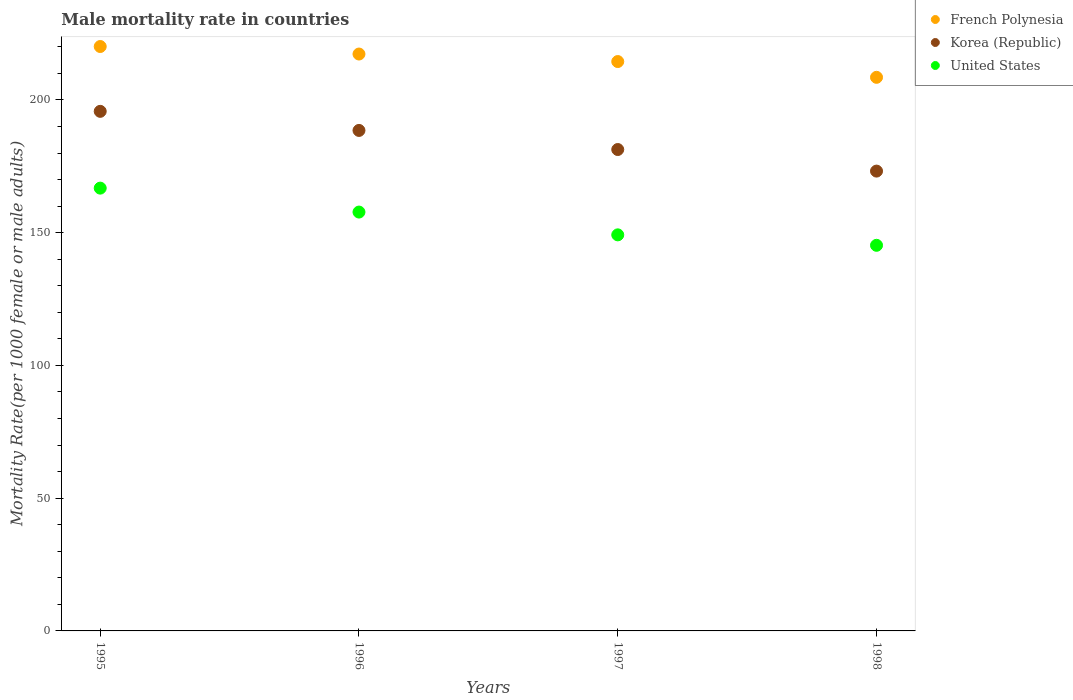Is the number of dotlines equal to the number of legend labels?
Offer a very short reply. Yes. What is the male mortality rate in Korea (Republic) in 1998?
Your response must be concise. 173.2. Across all years, what is the maximum male mortality rate in French Polynesia?
Provide a succinct answer. 220.13. Across all years, what is the minimum male mortality rate in French Polynesia?
Offer a terse response. 208.53. What is the total male mortality rate in French Polynesia in the graph?
Your answer should be very brief. 860.42. What is the difference between the male mortality rate in French Polynesia in 1995 and that in 1998?
Ensure brevity in your answer.  11.6. What is the difference between the male mortality rate in United States in 1995 and the male mortality rate in Korea (Republic) in 1996?
Your answer should be compact. -21.73. What is the average male mortality rate in United States per year?
Provide a succinct answer. 154.75. In the year 1995, what is the difference between the male mortality rate in Korea (Republic) and male mortality rate in French Polynesia?
Your answer should be compact. -24.42. What is the ratio of the male mortality rate in United States in 1996 to that in 1997?
Your answer should be compact. 1.06. Is the male mortality rate in French Polynesia in 1995 less than that in 1998?
Your answer should be compact. No. Is the difference between the male mortality rate in Korea (Republic) in 1995 and 1996 greater than the difference between the male mortality rate in French Polynesia in 1995 and 1996?
Give a very brief answer. Yes. What is the difference between the highest and the second highest male mortality rate in Korea (Republic)?
Keep it short and to the point. 7.19. What is the difference between the highest and the lowest male mortality rate in United States?
Offer a very short reply. 21.54. In how many years, is the male mortality rate in United States greater than the average male mortality rate in United States taken over all years?
Offer a very short reply. 2. Is the sum of the male mortality rate in United States in 1996 and 1998 greater than the maximum male mortality rate in Korea (Republic) across all years?
Offer a terse response. Yes. Is the male mortality rate in United States strictly greater than the male mortality rate in French Polynesia over the years?
Make the answer very short. No. Does the graph contain grids?
Offer a very short reply. No. How many legend labels are there?
Your answer should be very brief. 3. How are the legend labels stacked?
Offer a very short reply. Vertical. What is the title of the graph?
Your answer should be very brief. Male mortality rate in countries. What is the label or title of the X-axis?
Keep it short and to the point. Years. What is the label or title of the Y-axis?
Make the answer very short. Mortality Rate(per 1000 female or male adults). What is the Mortality Rate(per 1000 female or male adults) in French Polynesia in 1995?
Make the answer very short. 220.13. What is the Mortality Rate(per 1000 female or male adults) of Korea (Republic) in 1995?
Provide a short and direct response. 195.71. What is the Mortality Rate(per 1000 female or male adults) of United States in 1995?
Provide a short and direct response. 166.79. What is the Mortality Rate(per 1000 female or male adults) in French Polynesia in 1996?
Make the answer very short. 217.3. What is the Mortality Rate(per 1000 female or male adults) of Korea (Republic) in 1996?
Ensure brevity in your answer.  188.52. What is the Mortality Rate(per 1000 female or male adults) in United States in 1996?
Your answer should be very brief. 157.77. What is the Mortality Rate(per 1000 female or male adults) in French Polynesia in 1997?
Give a very brief answer. 214.47. What is the Mortality Rate(per 1000 female or male adults) in Korea (Republic) in 1997?
Ensure brevity in your answer.  181.33. What is the Mortality Rate(per 1000 female or male adults) of United States in 1997?
Provide a short and direct response. 149.19. What is the Mortality Rate(per 1000 female or male adults) of French Polynesia in 1998?
Your answer should be compact. 208.53. What is the Mortality Rate(per 1000 female or male adults) of Korea (Republic) in 1998?
Make the answer very short. 173.2. What is the Mortality Rate(per 1000 female or male adults) in United States in 1998?
Offer a very short reply. 145.25. Across all years, what is the maximum Mortality Rate(per 1000 female or male adults) of French Polynesia?
Your response must be concise. 220.13. Across all years, what is the maximum Mortality Rate(per 1000 female or male adults) of Korea (Republic)?
Keep it short and to the point. 195.71. Across all years, what is the maximum Mortality Rate(per 1000 female or male adults) of United States?
Give a very brief answer. 166.79. Across all years, what is the minimum Mortality Rate(per 1000 female or male adults) in French Polynesia?
Make the answer very short. 208.53. Across all years, what is the minimum Mortality Rate(per 1000 female or male adults) of Korea (Republic)?
Make the answer very short. 173.2. Across all years, what is the minimum Mortality Rate(per 1000 female or male adults) of United States?
Make the answer very short. 145.25. What is the total Mortality Rate(per 1000 female or male adults) in French Polynesia in the graph?
Ensure brevity in your answer.  860.42. What is the total Mortality Rate(per 1000 female or male adults) of Korea (Republic) in the graph?
Offer a terse response. 738.76. What is the total Mortality Rate(per 1000 female or male adults) of United States in the graph?
Keep it short and to the point. 619. What is the difference between the Mortality Rate(per 1000 female or male adults) in French Polynesia in 1995 and that in 1996?
Your answer should be compact. 2.83. What is the difference between the Mortality Rate(per 1000 female or male adults) of Korea (Republic) in 1995 and that in 1996?
Your answer should be compact. 7.19. What is the difference between the Mortality Rate(per 1000 female or male adults) of United States in 1995 and that in 1996?
Keep it short and to the point. 9.02. What is the difference between the Mortality Rate(per 1000 female or male adults) in French Polynesia in 1995 and that in 1997?
Give a very brief answer. 5.66. What is the difference between the Mortality Rate(per 1000 female or male adults) of Korea (Republic) in 1995 and that in 1997?
Make the answer very short. 14.38. What is the difference between the Mortality Rate(per 1000 female or male adults) in French Polynesia in 1995 and that in 1998?
Your answer should be very brief. 11.61. What is the difference between the Mortality Rate(per 1000 female or male adults) in Korea (Republic) in 1995 and that in 1998?
Your response must be concise. 22.51. What is the difference between the Mortality Rate(per 1000 female or male adults) in United States in 1995 and that in 1998?
Provide a succinct answer. 21.54. What is the difference between the Mortality Rate(per 1000 female or male adults) in French Polynesia in 1996 and that in 1997?
Offer a terse response. 2.83. What is the difference between the Mortality Rate(per 1000 female or male adults) of Korea (Republic) in 1996 and that in 1997?
Give a very brief answer. 7.19. What is the difference between the Mortality Rate(per 1000 female or male adults) of United States in 1996 and that in 1997?
Provide a short and direct response. 8.58. What is the difference between the Mortality Rate(per 1000 female or male adults) in French Polynesia in 1996 and that in 1998?
Offer a terse response. 8.77. What is the difference between the Mortality Rate(per 1000 female or male adults) in Korea (Republic) in 1996 and that in 1998?
Give a very brief answer. 15.32. What is the difference between the Mortality Rate(per 1000 female or male adults) in United States in 1996 and that in 1998?
Provide a short and direct response. 12.52. What is the difference between the Mortality Rate(per 1000 female or male adults) in French Polynesia in 1997 and that in 1998?
Your answer should be compact. 5.94. What is the difference between the Mortality Rate(per 1000 female or male adults) in Korea (Republic) in 1997 and that in 1998?
Make the answer very short. 8.13. What is the difference between the Mortality Rate(per 1000 female or male adults) of United States in 1997 and that in 1998?
Offer a terse response. 3.94. What is the difference between the Mortality Rate(per 1000 female or male adults) of French Polynesia in 1995 and the Mortality Rate(per 1000 female or male adults) of Korea (Republic) in 1996?
Your answer should be compact. 31.61. What is the difference between the Mortality Rate(per 1000 female or male adults) of French Polynesia in 1995 and the Mortality Rate(per 1000 female or male adults) of United States in 1996?
Your response must be concise. 62.36. What is the difference between the Mortality Rate(per 1000 female or male adults) of Korea (Republic) in 1995 and the Mortality Rate(per 1000 female or male adults) of United States in 1996?
Provide a short and direct response. 37.94. What is the difference between the Mortality Rate(per 1000 female or male adults) of French Polynesia in 1995 and the Mortality Rate(per 1000 female or male adults) of Korea (Republic) in 1997?
Your answer should be compact. 38.8. What is the difference between the Mortality Rate(per 1000 female or male adults) in French Polynesia in 1995 and the Mortality Rate(per 1000 female or male adults) in United States in 1997?
Provide a succinct answer. 70.94. What is the difference between the Mortality Rate(per 1000 female or male adults) in Korea (Republic) in 1995 and the Mortality Rate(per 1000 female or male adults) in United States in 1997?
Offer a terse response. 46.52. What is the difference between the Mortality Rate(per 1000 female or male adults) of French Polynesia in 1995 and the Mortality Rate(per 1000 female or male adults) of Korea (Republic) in 1998?
Offer a terse response. 46.93. What is the difference between the Mortality Rate(per 1000 female or male adults) of French Polynesia in 1995 and the Mortality Rate(per 1000 female or male adults) of United States in 1998?
Ensure brevity in your answer.  74.88. What is the difference between the Mortality Rate(per 1000 female or male adults) in Korea (Republic) in 1995 and the Mortality Rate(per 1000 female or male adults) in United States in 1998?
Ensure brevity in your answer.  50.46. What is the difference between the Mortality Rate(per 1000 female or male adults) of French Polynesia in 1996 and the Mortality Rate(per 1000 female or male adults) of Korea (Republic) in 1997?
Offer a terse response. 35.97. What is the difference between the Mortality Rate(per 1000 female or male adults) in French Polynesia in 1996 and the Mortality Rate(per 1000 female or male adults) in United States in 1997?
Make the answer very short. 68.11. What is the difference between the Mortality Rate(per 1000 female or male adults) of Korea (Republic) in 1996 and the Mortality Rate(per 1000 female or male adults) of United States in 1997?
Ensure brevity in your answer.  39.33. What is the difference between the Mortality Rate(per 1000 female or male adults) in French Polynesia in 1996 and the Mortality Rate(per 1000 female or male adults) in Korea (Republic) in 1998?
Keep it short and to the point. 44.09. What is the difference between the Mortality Rate(per 1000 female or male adults) of French Polynesia in 1996 and the Mortality Rate(per 1000 female or male adults) of United States in 1998?
Offer a terse response. 72.05. What is the difference between the Mortality Rate(per 1000 female or male adults) of Korea (Republic) in 1996 and the Mortality Rate(per 1000 female or male adults) of United States in 1998?
Ensure brevity in your answer.  43.27. What is the difference between the Mortality Rate(per 1000 female or male adults) of French Polynesia in 1997 and the Mortality Rate(per 1000 female or male adults) of Korea (Republic) in 1998?
Provide a short and direct response. 41.26. What is the difference between the Mortality Rate(per 1000 female or male adults) in French Polynesia in 1997 and the Mortality Rate(per 1000 female or male adults) in United States in 1998?
Your answer should be compact. 69.22. What is the difference between the Mortality Rate(per 1000 female or male adults) in Korea (Republic) in 1997 and the Mortality Rate(per 1000 female or male adults) in United States in 1998?
Your answer should be very brief. 36.08. What is the average Mortality Rate(per 1000 female or male adults) of French Polynesia per year?
Your response must be concise. 215.1. What is the average Mortality Rate(per 1000 female or male adults) in Korea (Republic) per year?
Offer a very short reply. 184.69. What is the average Mortality Rate(per 1000 female or male adults) of United States per year?
Offer a very short reply. 154.75. In the year 1995, what is the difference between the Mortality Rate(per 1000 female or male adults) of French Polynesia and Mortality Rate(per 1000 female or male adults) of Korea (Republic)?
Keep it short and to the point. 24.42. In the year 1995, what is the difference between the Mortality Rate(per 1000 female or male adults) in French Polynesia and Mortality Rate(per 1000 female or male adults) in United States?
Make the answer very short. 53.34. In the year 1995, what is the difference between the Mortality Rate(per 1000 female or male adults) of Korea (Republic) and Mortality Rate(per 1000 female or male adults) of United States?
Offer a terse response. 28.92. In the year 1996, what is the difference between the Mortality Rate(per 1000 female or male adults) in French Polynesia and Mortality Rate(per 1000 female or male adults) in Korea (Republic)?
Provide a short and direct response. 28.78. In the year 1996, what is the difference between the Mortality Rate(per 1000 female or male adults) in French Polynesia and Mortality Rate(per 1000 female or male adults) in United States?
Give a very brief answer. 59.53. In the year 1996, what is the difference between the Mortality Rate(per 1000 female or male adults) in Korea (Republic) and Mortality Rate(per 1000 female or male adults) in United States?
Your response must be concise. 30.75. In the year 1997, what is the difference between the Mortality Rate(per 1000 female or male adults) in French Polynesia and Mortality Rate(per 1000 female or male adults) in Korea (Republic)?
Make the answer very short. 33.14. In the year 1997, what is the difference between the Mortality Rate(per 1000 female or male adults) of French Polynesia and Mortality Rate(per 1000 female or male adults) of United States?
Your answer should be very brief. 65.28. In the year 1997, what is the difference between the Mortality Rate(per 1000 female or male adults) of Korea (Republic) and Mortality Rate(per 1000 female or male adults) of United States?
Give a very brief answer. 32.14. In the year 1998, what is the difference between the Mortality Rate(per 1000 female or male adults) of French Polynesia and Mortality Rate(per 1000 female or male adults) of Korea (Republic)?
Your answer should be compact. 35.32. In the year 1998, what is the difference between the Mortality Rate(per 1000 female or male adults) of French Polynesia and Mortality Rate(per 1000 female or male adults) of United States?
Your answer should be compact. 63.27. In the year 1998, what is the difference between the Mortality Rate(per 1000 female or male adults) in Korea (Republic) and Mortality Rate(per 1000 female or male adults) in United States?
Your answer should be very brief. 27.95. What is the ratio of the Mortality Rate(per 1000 female or male adults) of Korea (Republic) in 1995 to that in 1996?
Your answer should be compact. 1.04. What is the ratio of the Mortality Rate(per 1000 female or male adults) in United States in 1995 to that in 1996?
Provide a short and direct response. 1.06. What is the ratio of the Mortality Rate(per 1000 female or male adults) of French Polynesia in 1995 to that in 1997?
Give a very brief answer. 1.03. What is the ratio of the Mortality Rate(per 1000 female or male adults) of Korea (Republic) in 1995 to that in 1997?
Make the answer very short. 1.08. What is the ratio of the Mortality Rate(per 1000 female or male adults) of United States in 1995 to that in 1997?
Provide a succinct answer. 1.12. What is the ratio of the Mortality Rate(per 1000 female or male adults) in French Polynesia in 1995 to that in 1998?
Your response must be concise. 1.06. What is the ratio of the Mortality Rate(per 1000 female or male adults) in Korea (Republic) in 1995 to that in 1998?
Provide a short and direct response. 1.13. What is the ratio of the Mortality Rate(per 1000 female or male adults) of United States in 1995 to that in 1998?
Give a very brief answer. 1.15. What is the ratio of the Mortality Rate(per 1000 female or male adults) in French Polynesia in 1996 to that in 1997?
Your answer should be very brief. 1.01. What is the ratio of the Mortality Rate(per 1000 female or male adults) of Korea (Republic) in 1996 to that in 1997?
Offer a very short reply. 1.04. What is the ratio of the Mortality Rate(per 1000 female or male adults) in United States in 1996 to that in 1997?
Offer a terse response. 1.06. What is the ratio of the Mortality Rate(per 1000 female or male adults) in French Polynesia in 1996 to that in 1998?
Ensure brevity in your answer.  1.04. What is the ratio of the Mortality Rate(per 1000 female or male adults) of Korea (Republic) in 1996 to that in 1998?
Offer a terse response. 1.09. What is the ratio of the Mortality Rate(per 1000 female or male adults) in United States in 1996 to that in 1998?
Your response must be concise. 1.09. What is the ratio of the Mortality Rate(per 1000 female or male adults) of French Polynesia in 1997 to that in 1998?
Offer a very short reply. 1.03. What is the ratio of the Mortality Rate(per 1000 female or male adults) of Korea (Republic) in 1997 to that in 1998?
Your answer should be very brief. 1.05. What is the ratio of the Mortality Rate(per 1000 female or male adults) of United States in 1997 to that in 1998?
Make the answer very short. 1.03. What is the difference between the highest and the second highest Mortality Rate(per 1000 female or male adults) in French Polynesia?
Provide a succinct answer. 2.83. What is the difference between the highest and the second highest Mortality Rate(per 1000 female or male adults) in Korea (Republic)?
Your answer should be compact. 7.19. What is the difference between the highest and the second highest Mortality Rate(per 1000 female or male adults) in United States?
Your response must be concise. 9.02. What is the difference between the highest and the lowest Mortality Rate(per 1000 female or male adults) of French Polynesia?
Offer a very short reply. 11.61. What is the difference between the highest and the lowest Mortality Rate(per 1000 female or male adults) in Korea (Republic)?
Give a very brief answer. 22.51. What is the difference between the highest and the lowest Mortality Rate(per 1000 female or male adults) in United States?
Your answer should be very brief. 21.54. 